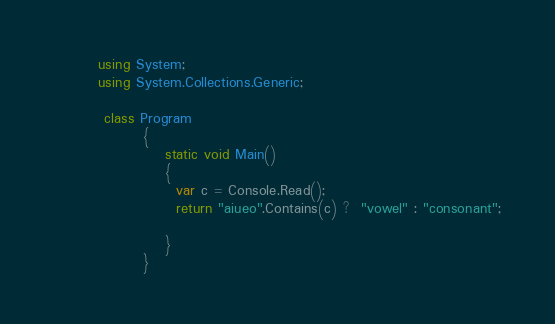<code> <loc_0><loc_0><loc_500><loc_500><_C#_>        using System;
        using System.Collections.Generic;

         class Program
                {
                    static void Main()
                    {
                      var c = Console.Read();
                      return "aiueo".Contains(c) ?  "vowel" : "consonant";
             
                    }
                }</code> 